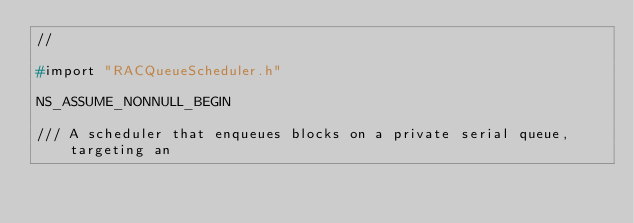<code> <loc_0><loc_0><loc_500><loc_500><_C_>//

#import "RACQueueScheduler.h"

NS_ASSUME_NONNULL_BEGIN

/// A scheduler that enqueues blocks on a private serial queue, targeting an</code> 